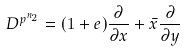Convert formula to latex. <formula><loc_0><loc_0><loc_500><loc_500>D ^ { p ^ { n _ { 2 } } } = ( 1 + e ) \frac { \partial } { \partial x } + \bar { x } \frac { \partial } { \partial y }</formula> 